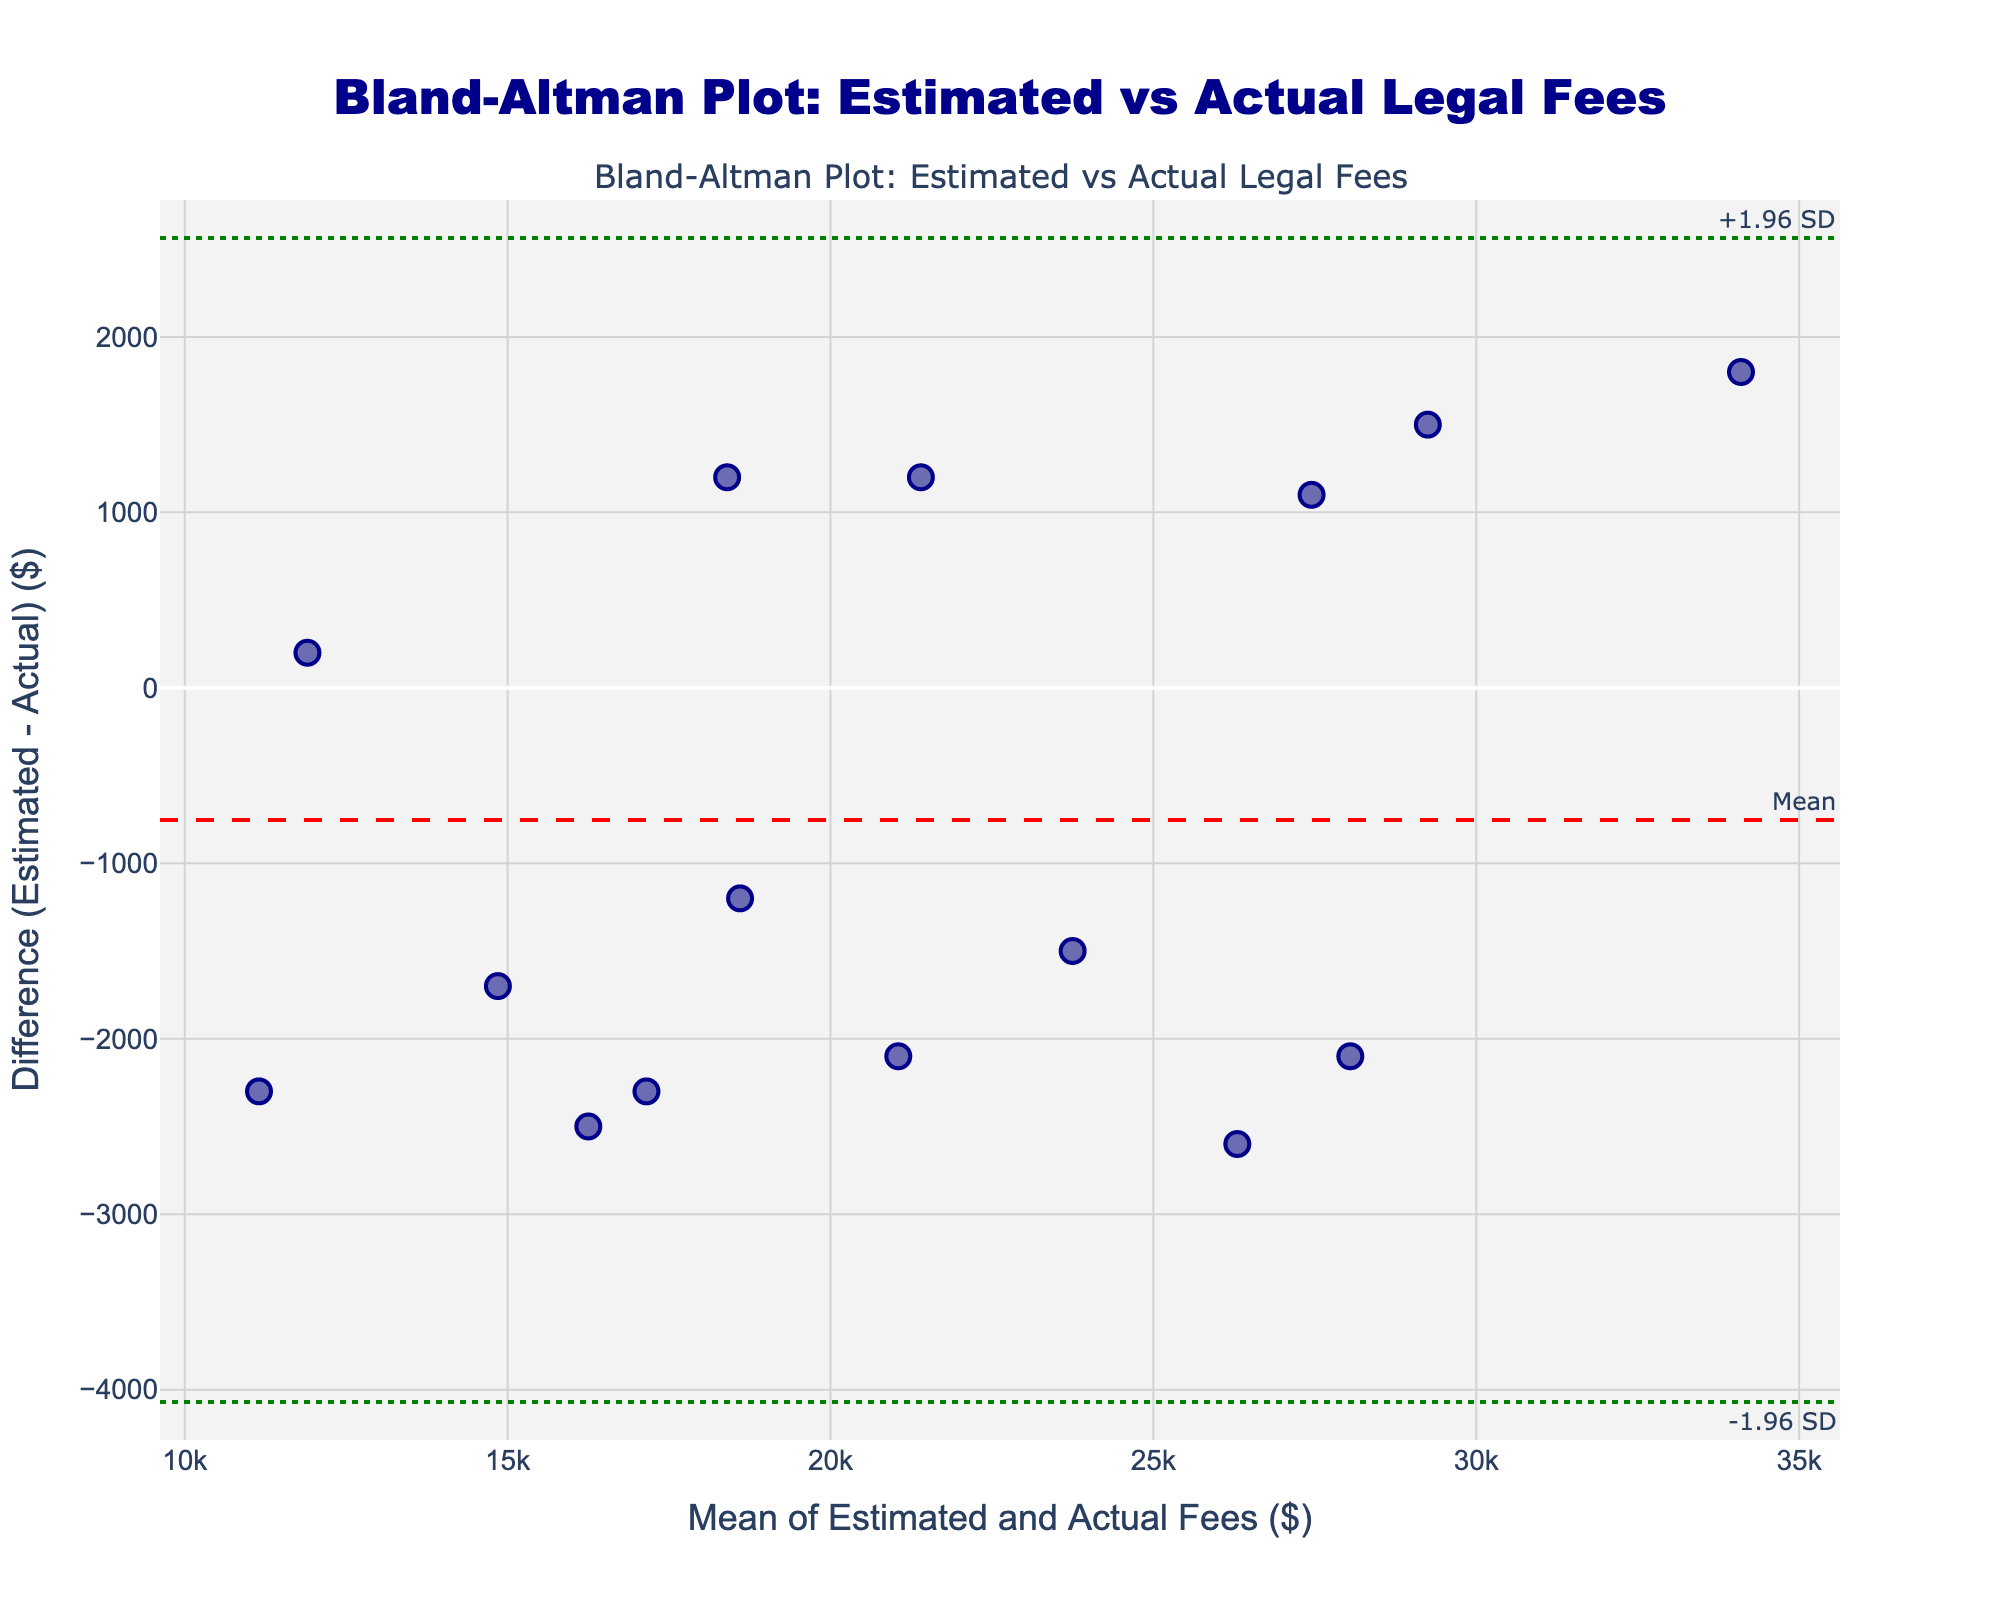what does the title of the plot indicate? The title of the plot indicates that the figure is a Bland-Altman Plot comparing estimated legal fees to actual billed amounts in divorce cases.
Answer: Bland-Altman Plot: Estimated vs Actual Legal Fees what is the mean of the differences between estimated and actual fees? The mean of the differences is indicated by the red dashed line on the plot. This line is annotated as "Mean".
Answer: About -100 what are the upper and lower limits of agreement on the plot? The upper limit is shown by the green dotted line annotated as "+1.96 SD" and the lower limit by the green dotted line annotated as "-1.96 SD".
Answer: Approximately 3434.57 (upper) and -3634.57 (lower) how many data points are shown in the plot? Each blue dot on the plot represents a data point. Counting these, we can determine the number of data points.
Answer: 15 what is the difference between the estimated and actual fees for the most extreme data point? The data point that is the furthest away from the horizontal register zero is the most extreme. By checking the y-axis values, we identify the difference of the most extreme point.
Answer: -4000 which axis represents the mean of estimated and actual fees? The x-axis title indicates that it represents the mean of the estimated and actual fees.
Answer: x-axis which axis represents the difference between estimated and actual fees? The y-axis title indicates that it represents the difference between the estimated and actual fees.
Answer: y-axis is there a general trend observable in how the differences distribute relative to the mean of the fees? Observing the scatter plot, we can identify if there is any clustering or trend such as increasing or decreasing variance with increasing mean.
Answer: No clear trend do most estimated fees tend to be higher or lower than actual fees? By looking at the scatter points relative to the zero-difference line, we can see whether more points are above or below the line.
Answer: Lower 